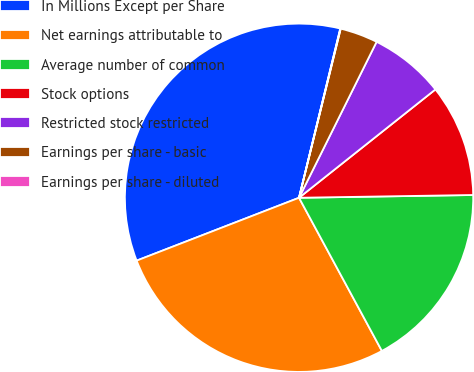Convert chart to OTSL. <chart><loc_0><loc_0><loc_500><loc_500><pie_chart><fcel>In Millions Except per Share<fcel>Net earnings attributable to<fcel>Average number of common<fcel>Stock options<fcel>Restricted stock restricted<fcel>Earnings per share - basic<fcel>Earnings per share - diluted<nl><fcel>34.68%<fcel>27.01%<fcel>17.36%<fcel>10.43%<fcel>6.97%<fcel>3.5%<fcel>0.04%<nl></chart> 